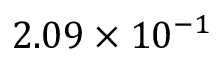Convert formula to latex. <formula><loc_0><loc_0><loc_500><loc_500>2 . 0 9 \times 1 0 ^ { - 1 }</formula> 